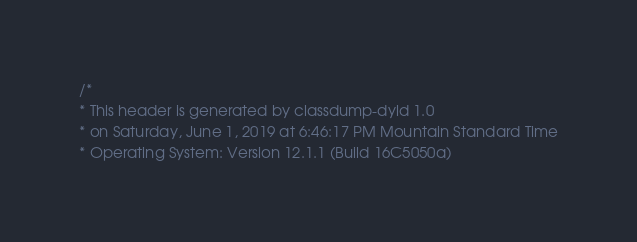<code> <loc_0><loc_0><loc_500><loc_500><_C_>/*
* This header is generated by classdump-dyld 1.0
* on Saturday, June 1, 2019 at 6:46:17 PM Mountain Standard Time
* Operating System: Version 12.1.1 (Build 16C5050a)</code> 